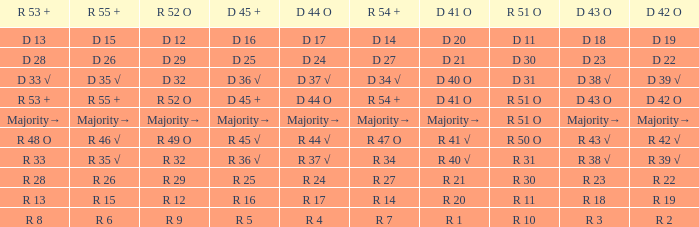What is the value of D 43 O that has a corresponding R 53 + value of r 8? R 3. Can you parse all the data within this table? {'header': ['R 53 +', 'R 55 +', 'R 52 O', 'D 45 +', 'D 44 O', 'R 54 +', 'D 41 O', 'R 51 O', 'D 43 O', 'D 42 O'], 'rows': [['D 13', 'D 15', 'D 12', 'D 16', 'D 17', 'D 14', 'D 20', 'D 11', 'D 18', 'D 19'], ['D 28', 'D 26', 'D 29', 'D 25', 'D 24', 'D 27', 'D 21', 'D 30', 'D 23', 'D 22'], ['D 33 √', 'D 35 √', 'D 32', 'D 36 √', 'D 37 √', 'D 34 √', 'D 40 O', 'D 31', 'D 38 √', 'D 39 √'], ['R 53 +', 'R 55 +', 'R 52 O', 'D 45 +', 'D 44 O', 'R 54 +', 'D 41 O', 'R 51 O', 'D 43 O', 'D 42 O'], ['Majority→', 'Majority→', 'Majority→', 'Majority→', 'Majority→', 'Majority→', 'Majority→', 'R 51 O', 'Majority→', 'Majority→'], ['R 48 O', 'R 46 √', 'R 49 O', 'R 45 √', 'R 44 √', 'R 47 O', 'R 41 √', 'R 50 O', 'R 43 √', 'R 42 √'], ['R 33', 'R 35 √', 'R 32', 'R 36 √', 'R 37 √', 'R 34', 'R 40 √', 'R 31', 'R 38 √', 'R 39 √'], ['R 28', 'R 26', 'R 29', 'R 25', 'R 24', 'R 27', 'R 21', 'R 30', 'R 23', 'R 22'], ['R 13', 'R 15', 'R 12', 'R 16', 'R 17', 'R 14', 'R 20', 'R 11', 'R 18', 'R 19'], ['R 8', 'R 6', 'R 9', 'R 5', 'R 4', 'R 7', 'R 1', 'R 10', 'R 3', 'R 2']]} 